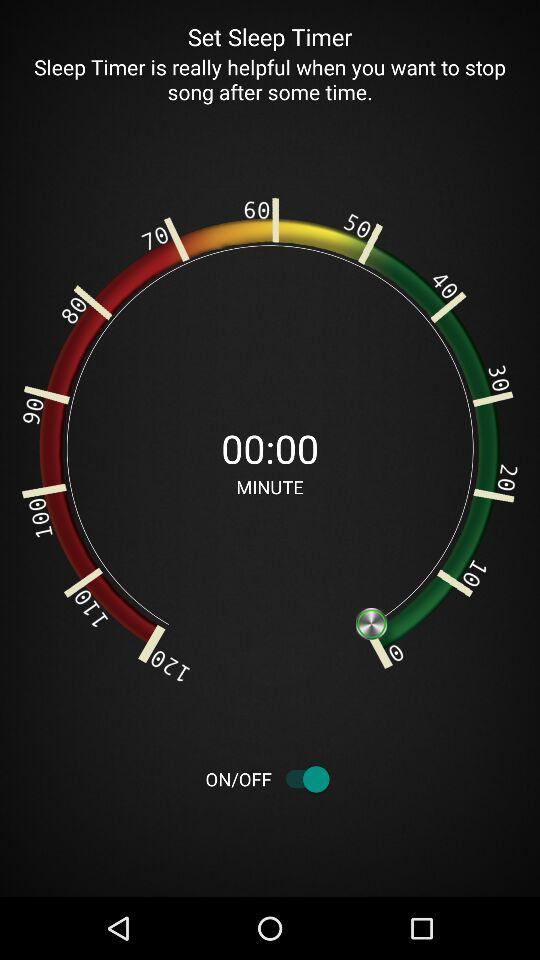What is the status of "Set Sleep Timer"? The status is "on". 